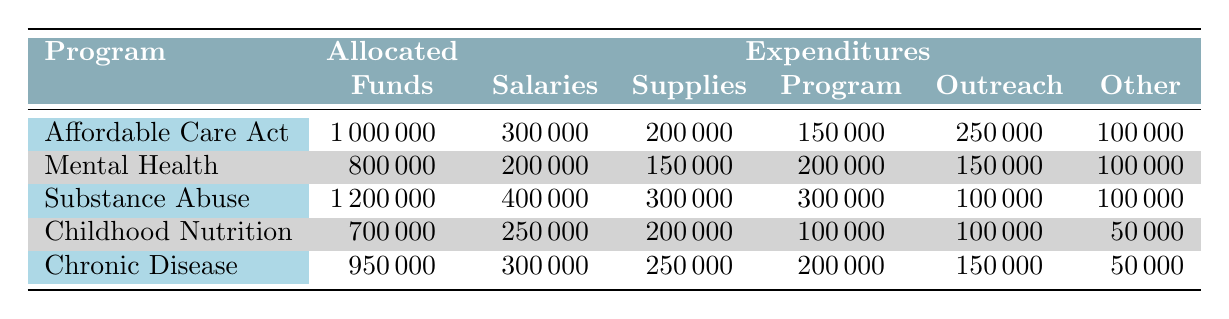What is the total amount allocated to all community health programs for 2023? To find the total amount allocated, add the allocated funds of all programs: 1,000,000 (Affordable Care Act Outreach) + 800,000 (Mental Health Awareness Campaign) + 1,200,000 (Substance Abuse Prevention and Treatment) + 700,000 (Childhood Nutrition Programs) + 950,000 (Chronic Disease Prevention) = 3,650,000
Answer: 3,650,000 Which program had the highest expenditures for supplies? By comparing the expenditures for supplies across all programs: 200,000 (Affordable Care Act Outreach), 150,000 (Mental Health Awareness Campaign), 300,000 (Substance Abuse Prevention and Treatment), 200,000 (Childhood Nutrition Programs), and 250,000 (Chronic Disease Prevention), the highest is 300,000 for Substance Abuse Prevention and Treatment.
Answer: Substance Abuse Prevention and Treatment What percentage of the allocated funds for the Mental Health Awareness Campaign was spent on salaries? To find the percentage, divide the salaries by the allocated funds: (200,000 / 800,000) * 100 = 25%.
Answer: 25% Did the Childhood Nutrition Programs spend more on salaries than on supplies? The expenditures are 250,000 on salaries and 200,000 on supplies. Since 250,000 is more than 200,000, the answer is yes.
Answer: Yes What is the average expenditure on other expenses across all community health programs? To calculate the average, first sum the other expenses: 100,000 (Affordable Care Act Outreach) + 100,000 (Mental Health Awareness Campaign) + 100,000 (Substance Abuse Prevention and Treatment) + 50,000 (Childhood Nutrition Programs) + 50,000 (Chronic Disease Prevention) = 400,000. Then divide by the number of programs (5): 400,000 / 5 = 80,000.
Answer: 80,000 Which program had the smallest allocated funds? The programs are compared based on their allocated funds: 1,000,000 (Affordable Care Act Outreach), 800,000 (Mental Health Awareness Campaign), 1,200,000 (Substance Abuse Prevention and Treatment), 700,000 (Childhood Nutrition Programs), and 950,000 (Chronic Disease Prevention). The smallest is 700,000 for Childhood Nutrition Programs.
Answer: Childhood Nutrition Programs How much was spent on public outreach campaigns compared to screening services? The expense on public outreach campaigns is 250,000 (Affordable Care Act Outreach), while screening services expenditure is 200,000 (Chronic Disease Prevention). Therefore, more was spent on public outreach campaigns since 250,000 > 200,000.
Answer: Public outreach campaigns What is the total expenditure for the Substance Abuse Prevention and Treatment program? To find the total expenditure for this program, add all the expenditure components: 400,000 (Salaries) + 300,000 (Supplies) + 300,000 (Treatment Programs) + 100,000 (Community Outreach) + 100,000 (Other Expenses) = 1,200,000.
Answer: 1,200,000 